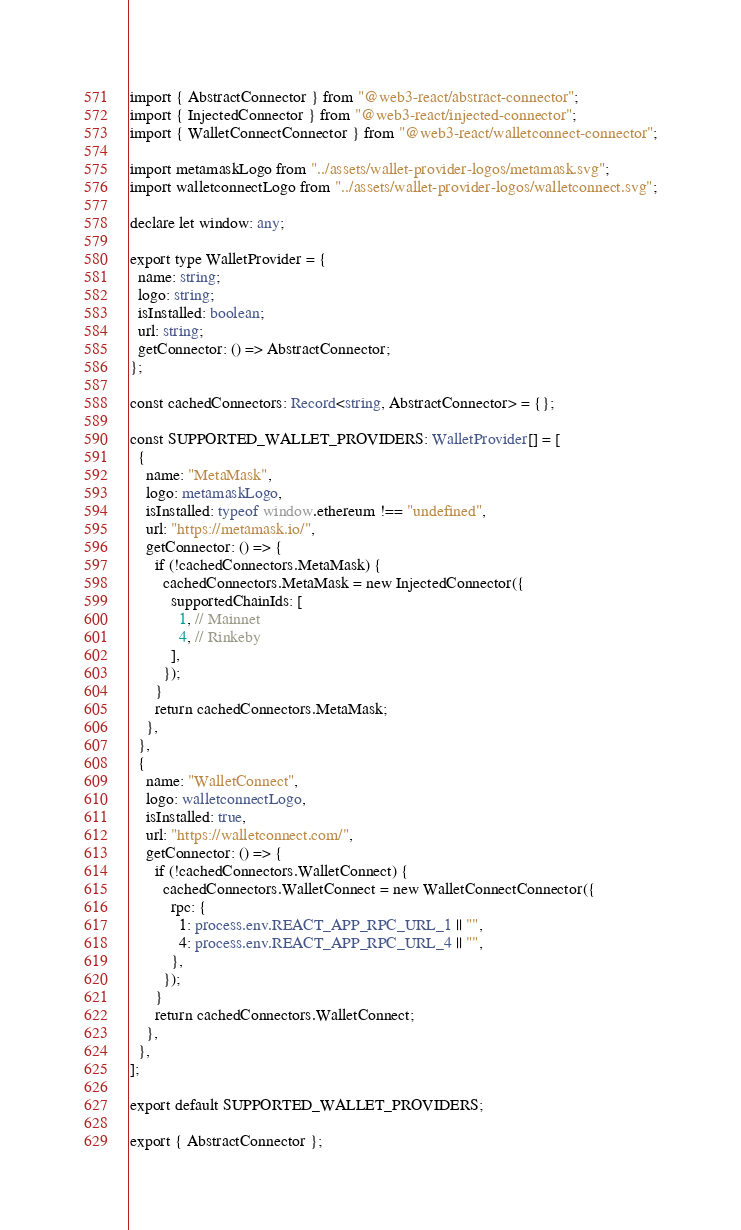Convert code to text. <code><loc_0><loc_0><loc_500><loc_500><_TypeScript_>import { AbstractConnector } from "@web3-react/abstract-connector";
import { InjectedConnector } from "@web3-react/injected-connector";
import { WalletConnectConnector } from "@web3-react/walletconnect-connector";

import metamaskLogo from "../assets/wallet-provider-logos/metamask.svg";
import walletconnectLogo from "../assets/wallet-provider-logos/walletconnect.svg";

declare let window: any;

export type WalletProvider = {
  name: string;
  logo: string;
  isInstalled: boolean;
  url: string;
  getConnector: () => AbstractConnector;
};

const cachedConnectors: Record<string, AbstractConnector> = {};

const SUPPORTED_WALLET_PROVIDERS: WalletProvider[] = [
  {
    name: "MetaMask",
    logo: metamaskLogo,
    isInstalled: typeof window.ethereum !== "undefined",
    url: "https://metamask.io/",
    getConnector: () => {
      if (!cachedConnectors.MetaMask) {
        cachedConnectors.MetaMask = new InjectedConnector({
          supportedChainIds: [
            1, // Mainnet
            4, // Rinkeby
          ],
        });
      }
      return cachedConnectors.MetaMask;
    },
  },
  {
    name: "WalletConnect",
    logo: walletconnectLogo,
    isInstalled: true,
    url: "https://walletconnect.com/",
    getConnector: () => {
      if (!cachedConnectors.WalletConnect) {
        cachedConnectors.WalletConnect = new WalletConnectConnector({
          rpc: {
            1: process.env.REACT_APP_RPC_URL_1 || "",
            4: process.env.REACT_APP_RPC_URL_4 || "",
          },
        });
      }
      return cachedConnectors.WalletConnect;
    },
  },
];

export default SUPPORTED_WALLET_PROVIDERS;

export { AbstractConnector };
</code> 